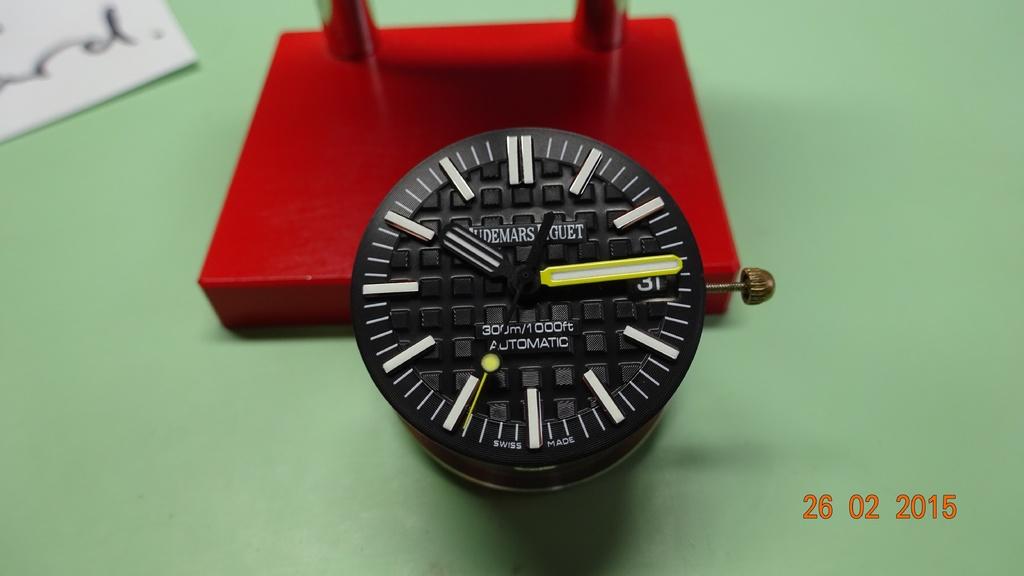What is the time on the watch?
Offer a very short reply. 10:15. When is this photo taken?
Make the answer very short. 26.02.2015. 